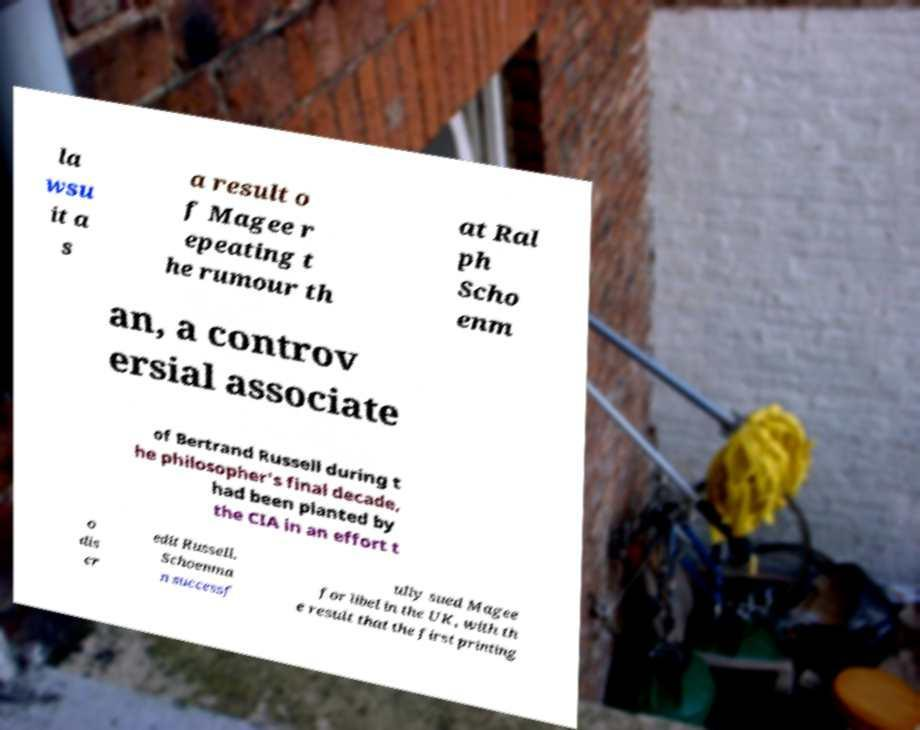What messages or text are displayed in this image? I need them in a readable, typed format. la wsu it a s a result o f Magee r epeating t he rumour th at Ral ph Scho enm an, a controv ersial associate of Bertrand Russell during t he philosopher's final decade, had been planted by the CIA in an effort t o dis cr edit Russell. Schoenma n successf ully sued Magee for libel in the UK, with th e result that the first printing 